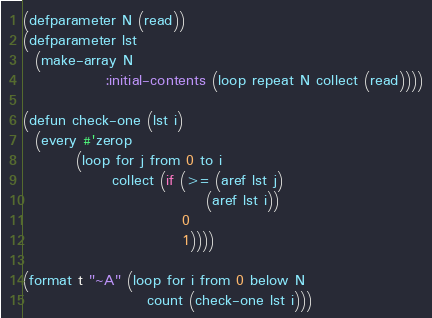<code> <loc_0><loc_0><loc_500><loc_500><_Lisp_>(defparameter N (read))
(defparameter lst 
  (make-array N 
              :initial-contents (loop repeat N collect (read))))

(defun check-one (lst i)
  (every #'zerop
         (loop for j from 0 to i
               collect (if (>= (aref lst j)
                               (aref lst i))
                           0
                           1))))

(format t "~A" (loop for i from 0 below N
                     count (check-one lst i)))</code> 